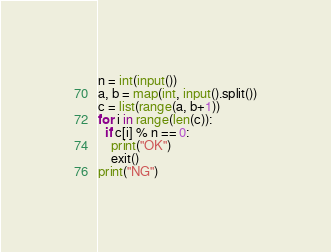<code> <loc_0><loc_0><loc_500><loc_500><_Python_>n = int(input())
a, b = map(int, input().split())
c = list(range(a, b+1))
for i in range(len(c)):
  if c[i] % n == 0:
    print("OK")
    exit()
print("NG")</code> 